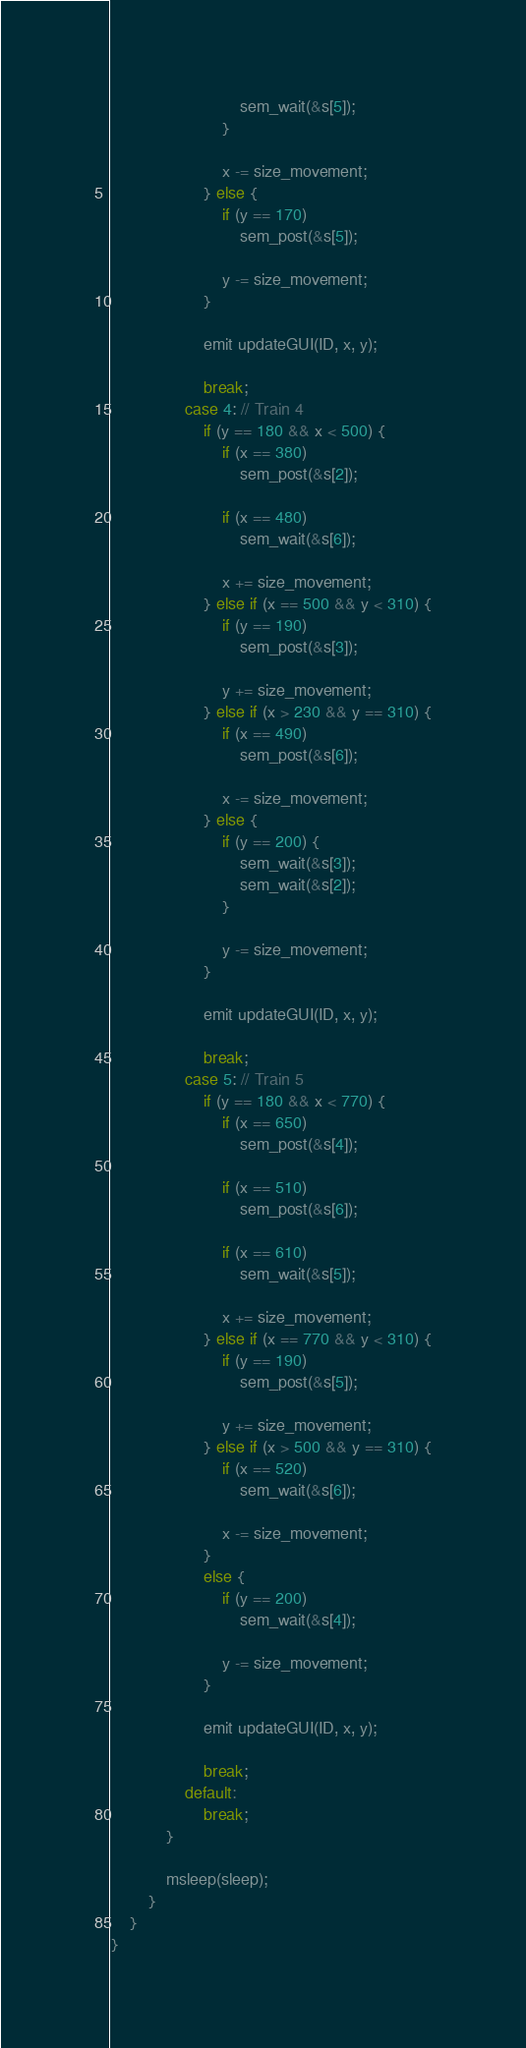<code> <loc_0><loc_0><loc_500><loc_500><_C++_>                            sem_wait(&s[5]);
                        }

                        x -= size_movement;
                    } else {
                        if (y == 170)
                            sem_post(&s[5]);

                        y -= size_movement;
                    }

                    emit updateGUI(ID, x, y);

                    break;
                case 4: // Train 4
                    if (y == 180 && x < 500) {
                        if (x == 380)
                            sem_post(&s[2]);

                        if (x == 480)
                            sem_wait(&s[6]);

                        x += size_movement;
                    } else if (x == 500 && y < 310) {
                        if (y == 190)
                            sem_post(&s[3]);

                        y += size_movement;
                    } else if (x > 230 && y == 310) {
                        if (x == 490)
                            sem_post(&s[6]);

                        x -= size_movement;
                    } else {
                        if (y == 200) {
                            sem_wait(&s[3]);
                            sem_wait(&s[2]);
                        }

                        y -= size_movement;
                    }

                    emit updateGUI(ID, x, y);

                    break;
                case 5: // Train 5
                    if (y == 180 && x < 770) {
                        if (x == 650)
                            sem_post(&s[4]);

                        if (x == 510)
                            sem_post(&s[6]);

                        if (x == 610)
                            sem_wait(&s[5]);

                        x += size_movement;
                    } else if (x == 770 && y < 310) {
                        if (y == 190)
                            sem_post(&s[5]);

                        y += size_movement;
                    } else if (x > 500 && y == 310) {
                        if (x == 520)
                            sem_wait(&s[6]);

                        x -= size_movement;
                    }
                    else {
                        if (y == 200)
                            sem_wait(&s[4]);

                        y -= size_movement;
                    }

                    emit updateGUI(ID, x, y);

                    break;
                default:
                    break;
            }

            msleep(sleep);
        }
    }
}
</code> 